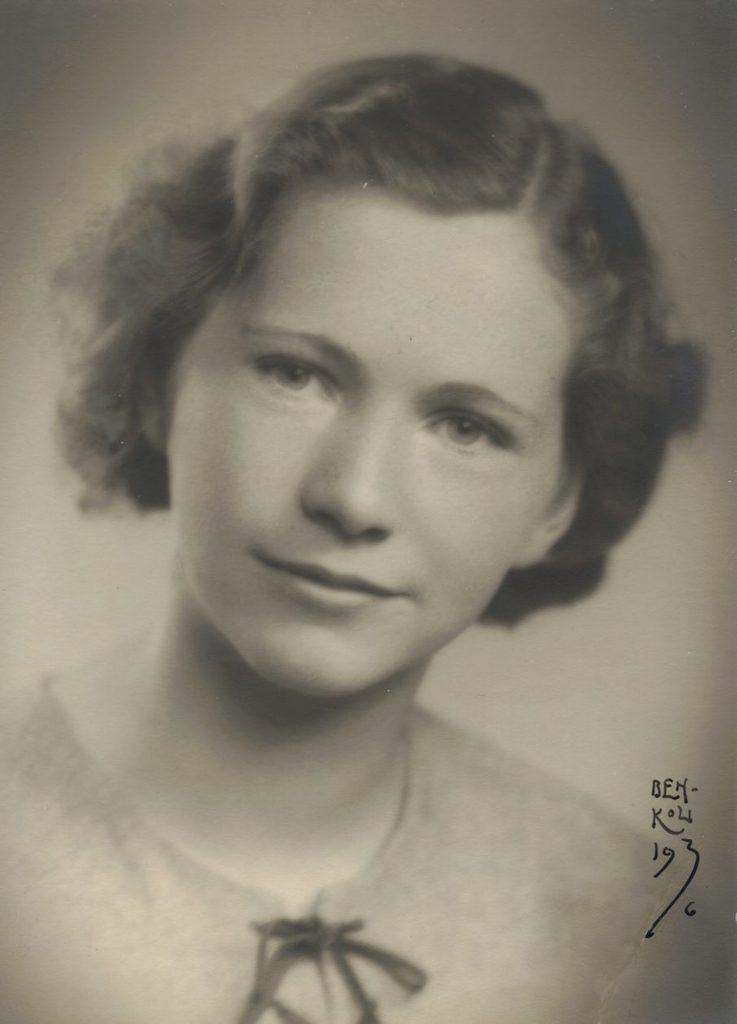Who is the main subject in the image? There is a woman in the image. What is the woman doing in the image? The woman is looking forward. Can you describe the background of the image? The background of the image is blurred. Is there any additional information or markings on the image? Yes, there is a watermark on the right side of the image. What type of science discussion is happening in the image? There is no discussion or reference to science in the image; it features a woman looking forward with a blurred background and a watermark. 